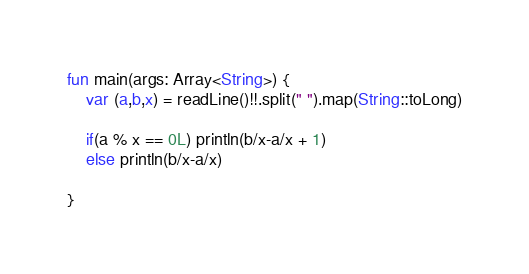Convert code to text. <code><loc_0><loc_0><loc_500><loc_500><_Kotlin_>fun main(args: Array<String>) {
    var (a,b,x) = readLine()!!.split(" ").map(String::toLong)
    
    if(a % x == 0L) println(b/x-a/x + 1)
    else println(b/x-a/x)
    
}
</code> 